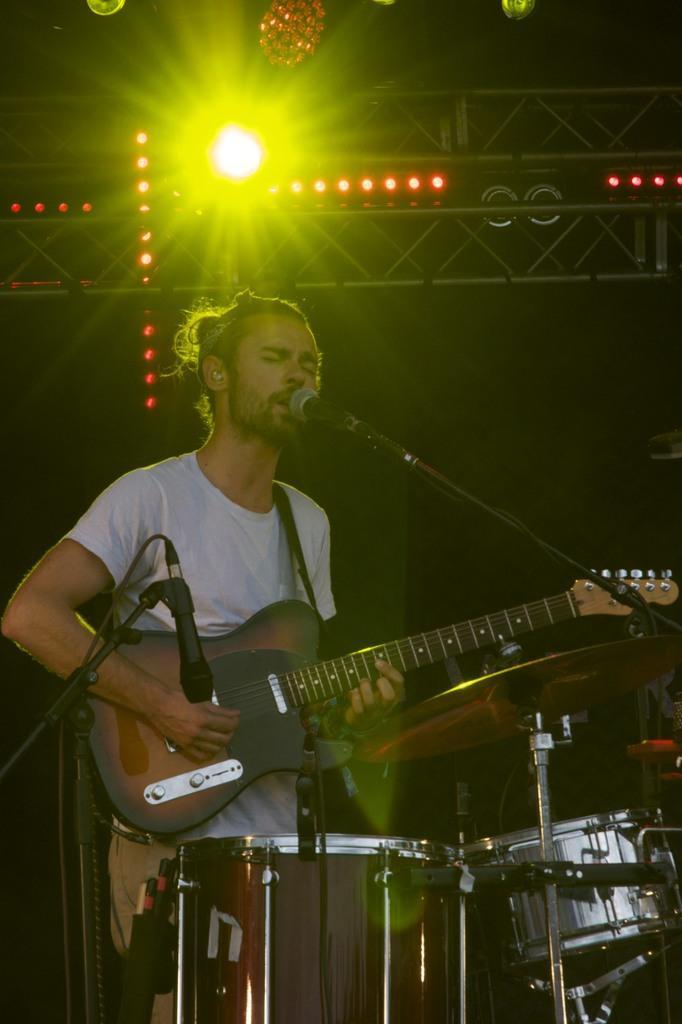Could you give a brief overview of what you see in this image? In this picture there is a man singing in front of the mic holding a guitar in his hand with the drums in front of him and a mic at the left side. In the background there is a focus light and a black colour sheet. 